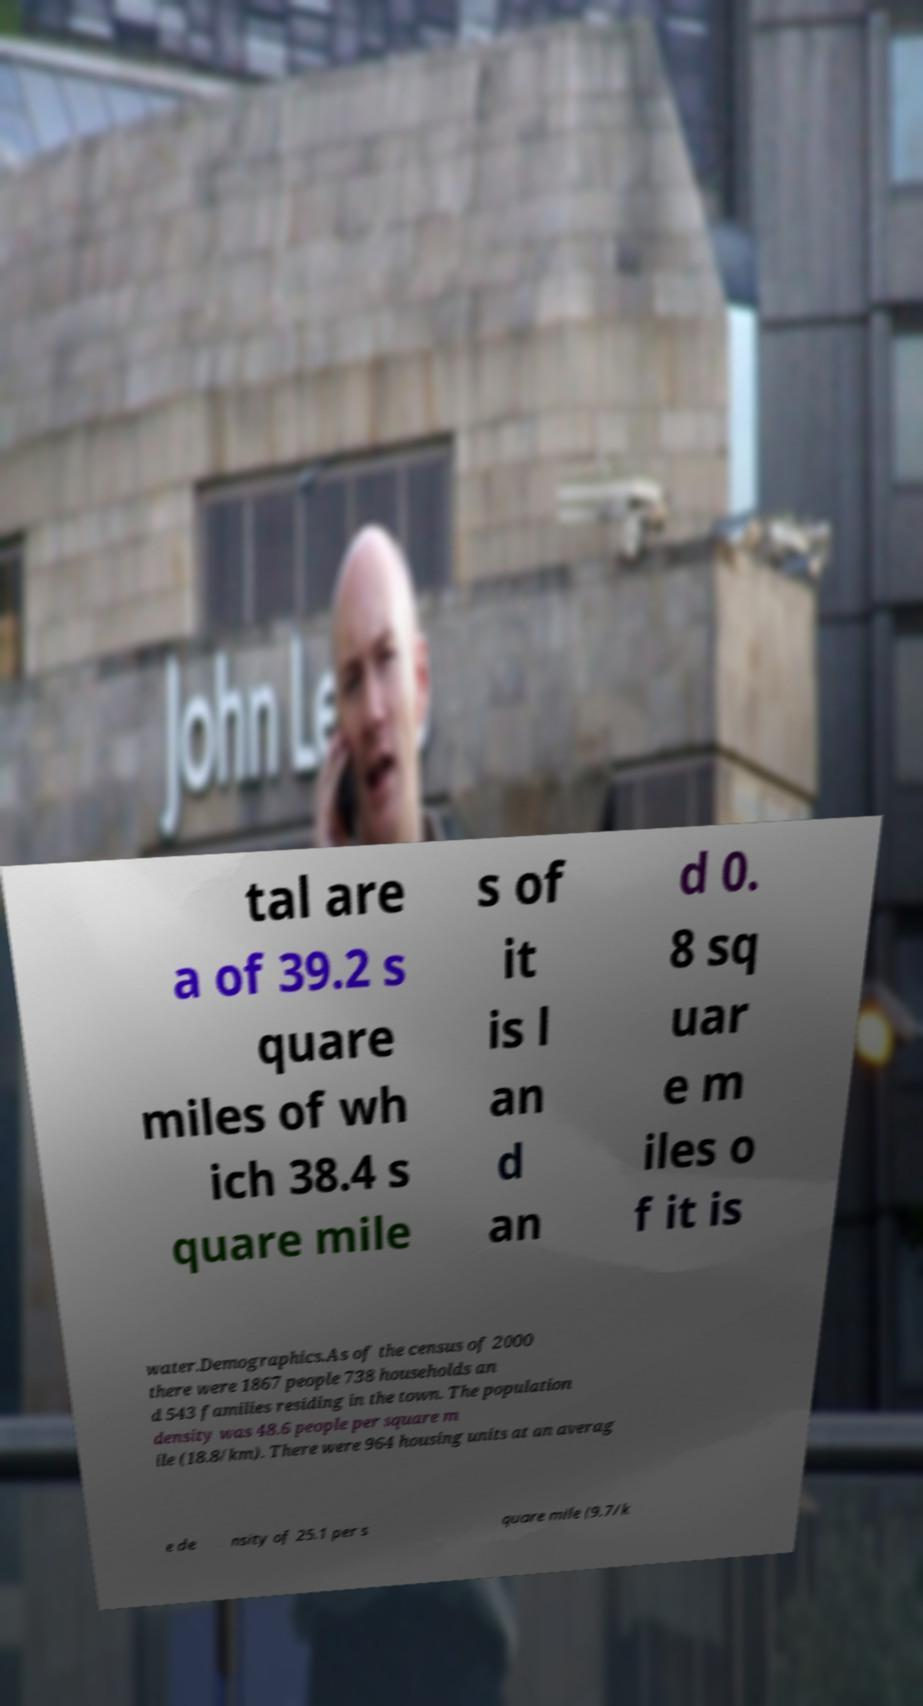Please identify and transcribe the text found in this image. tal are a of 39.2 s quare miles of wh ich 38.4 s quare mile s of it is l an d an d 0. 8 sq uar e m iles o f it is water.Demographics.As of the census of 2000 there were 1867 people 738 households an d 543 families residing in the town. The population density was 48.6 people per square m ile (18.8/km). There were 964 housing units at an averag e de nsity of 25.1 per s quare mile (9.7/k 